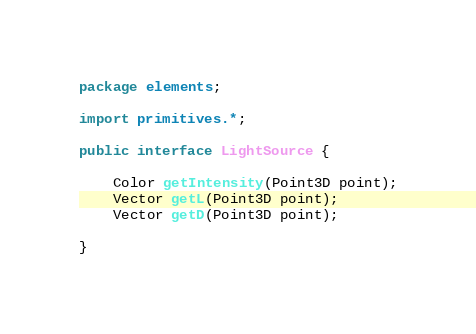Convert code to text. <code><loc_0><loc_0><loc_500><loc_500><_Java_>package elements;

import primitives.*;

public interface LightSource {

	Color getIntensity(Point3D point);
	Vector getL(Point3D point);
	Vector getD(Point3D point);
	
}
</code> 